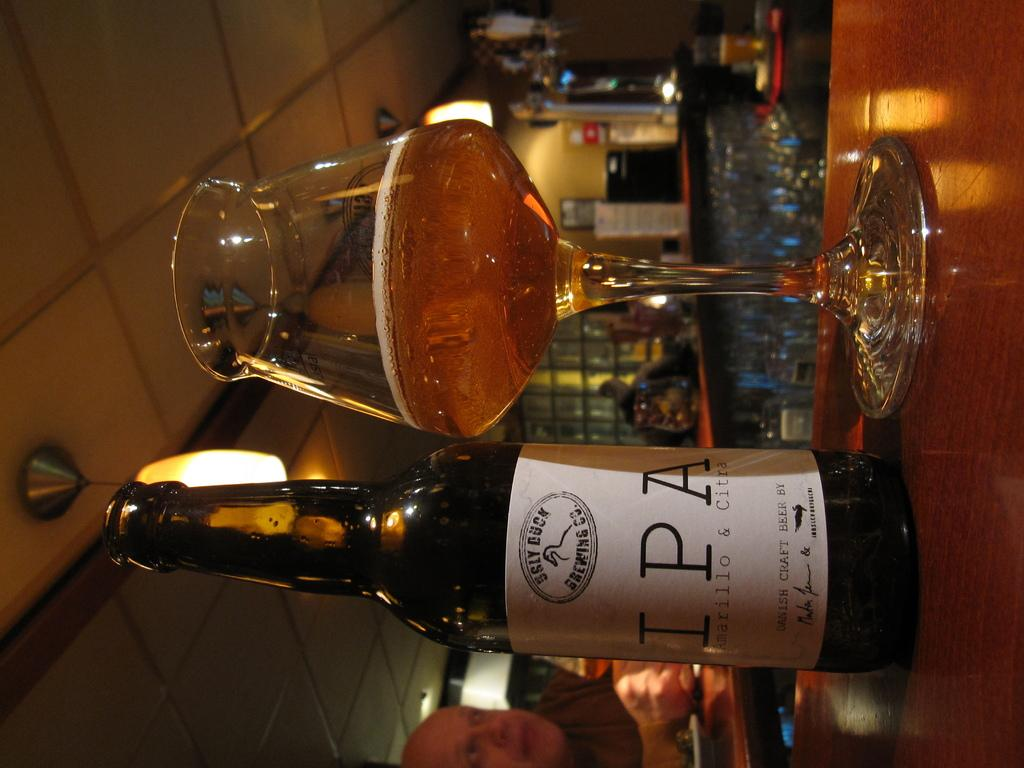<image>
Create a compact narrative representing the image presented. A bottle of IPA stitting on a wooden bar. 